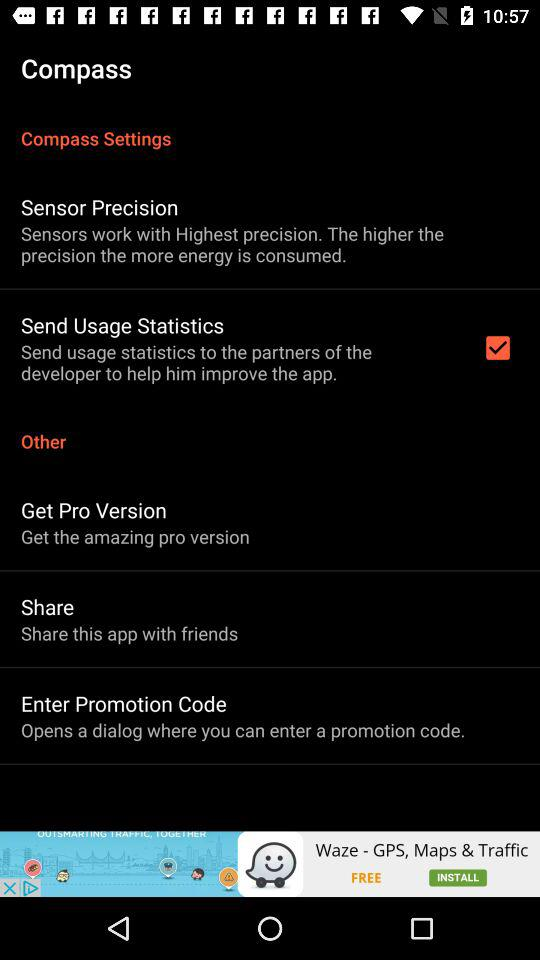What is the status of "Send Usage Statistics"? The status is "on". 